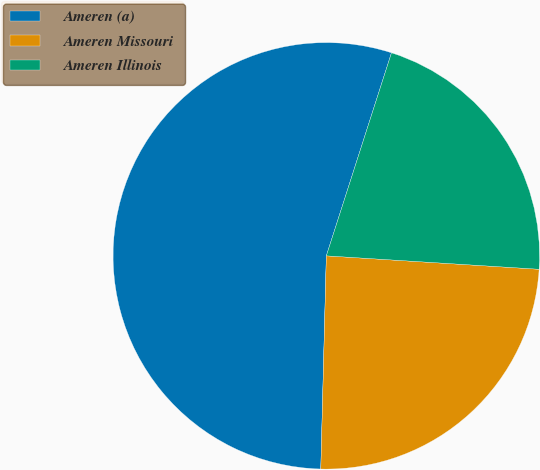Convert chart to OTSL. <chart><loc_0><loc_0><loc_500><loc_500><pie_chart><fcel>Ameren (a)<fcel>Ameren Missouri<fcel>Ameren Illinois<nl><fcel>54.53%<fcel>24.41%<fcel>21.06%<nl></chart> 